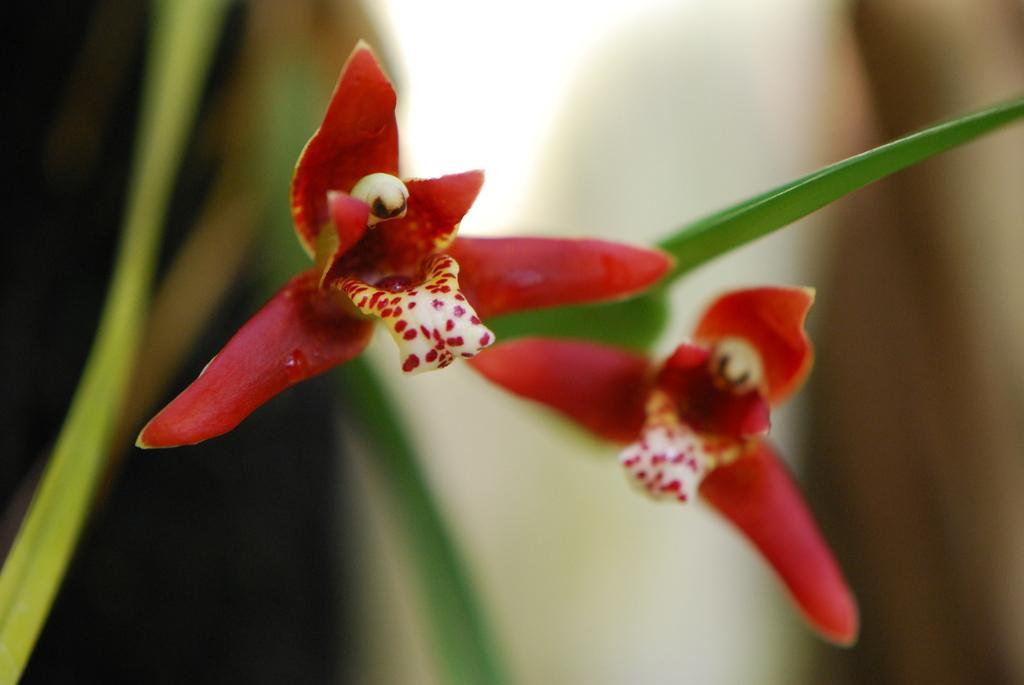How would you summarize this image in a sentence or two? In this image in front there are flowers, leaves and the background of the image is blur. 